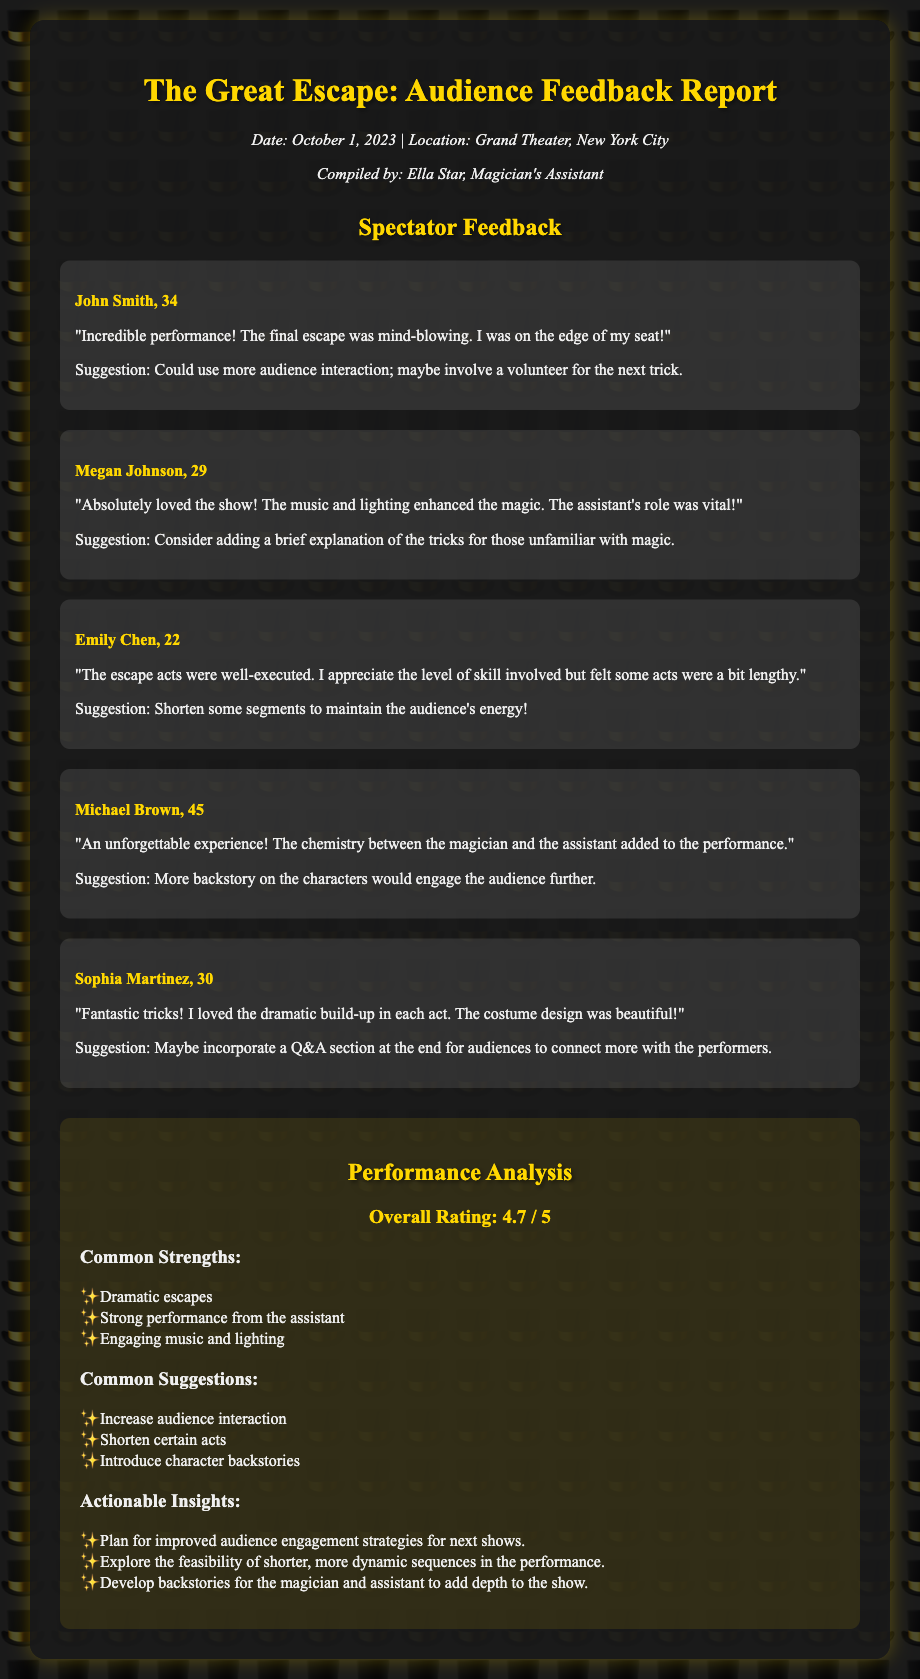What is the overall rating? The overall rating is summarized in the performance analysis section, which states the rating out of 5.
Answer: 4.7 / 5 Who compiled the report? The document lists the person responsible for compiling the report at the top section.
Answer: Ella Star What was one suggestion from a spectator? The suggestions from spectators are included after their reviews within the feedback section.
Answer: Could use more audience interaction How many feedback items are included? The total number of feedback items can be counted from the feedback section in the document.
Answer: 5 What date was the performance held? The specific date of the performance is mentioned in the show information section.
Answer: October 1, 2023 Which aspect received praise regarding the assistant? The strengths section highlights the performance of the assistant as a common strength.
Answer: Strong performance from the assistant What is a common suggestion mentioned by spectators? The common suggestions are summarized towards the end of the analysis section of the document.
Answer: Increase audience interaction What performance location is mentioned? The document specifies the location where the performance took place in the show information section.
Answer: Grand Theater, New York City 